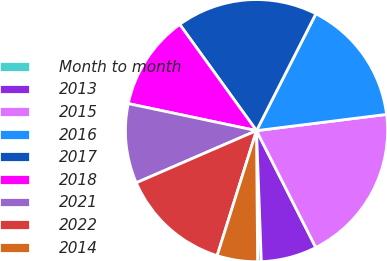<chart> <loc_0><loc_0><loc_500><loc_500><pie_chart><fcel>Month to month<fcel>2013<fcel>2015<fcel>2016<fcel>2017<fcel>2018<fcel>2021<fcel>2022<fcel>2014<nl><fcel>0.45%<fcel>6.89%<fcel>19.5%<fcel>15.54%<fcel>17.44%<fcel>11.73%<fcel>9.82%<fcel>13.63%<fcel>4.99%<nl></chart> 